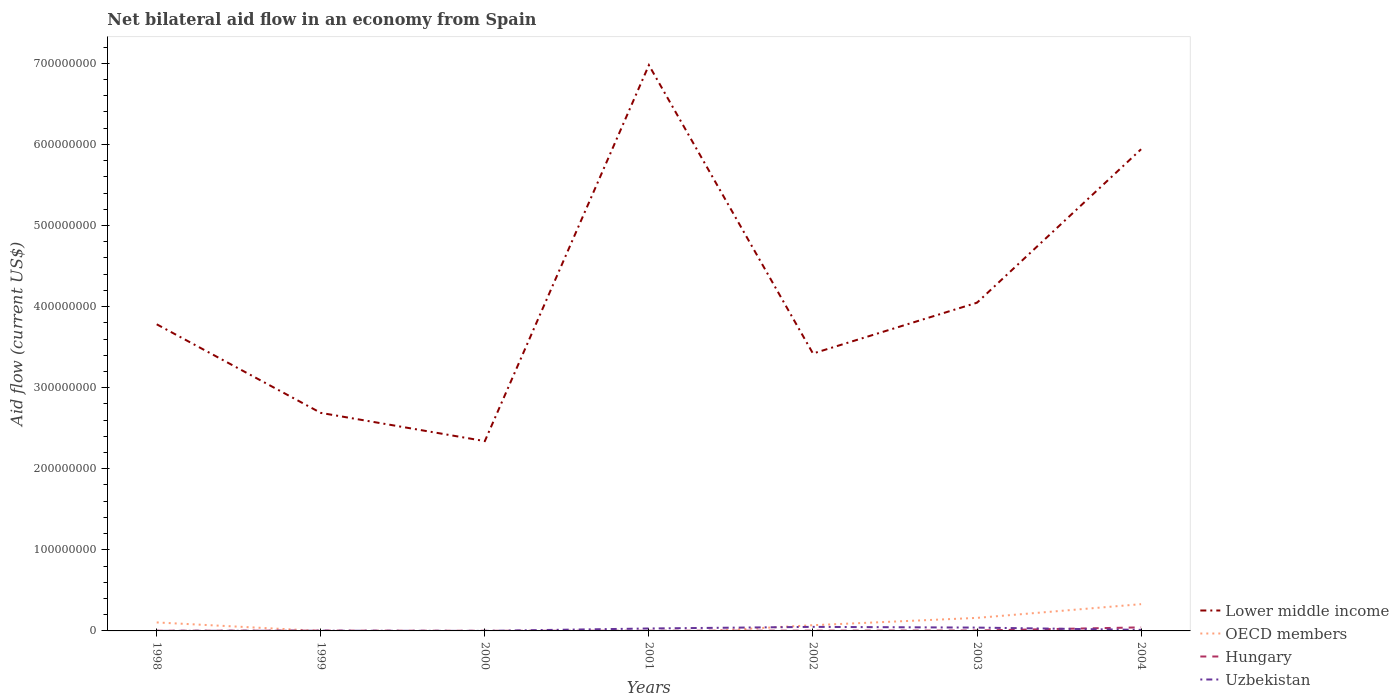Across all years, what is the maximum net bilateral aid flow in Uzbekistan?
Your answer should be very brief. 3.00e+04. What is the total net bilateral aid flow in Uzbekistan in the graph?
Your response must be concise. -4.92e+06. What is the difference between the highest and the second highest net bilateral aid flow in Lower middle income?
Keep it short and to the point. 4.64e+08. What is the difference between the highest and the lowest net bilateral aid flow in Hungary?
Your answer should be compact. 1. How many lines are there?
Provide a short and direct response. 4. How many years are there in the graph?
Your answer should be very brief. 7. Does the graph contain any zero values?
Ensure brevity in your answer.  Yes. Where does the legend appear in the graph?
Offer a very short reply. Bottom right. What is the title of the graph?
Provide a succinct answer. Net bilateral aid flow in an economy from Spain. What is the label or title of the X-axis?
Your answer should be compact. Years. What is the Aid flow (current US$) in Lower middle income in 1998?
Keep it short and to the point. 3.78e+08. What is the Aid flow (current US$) of OECD members in 1998?
Keep it short and to the point. 1.05e+07. What is the Aid flow (current US$) in Uzbekistan in 1998?
Offer a terse response. 7.00e+04. What is the Aid flow (current US$) in Lower middle income in 1999?
Your answer should be very brief. 2.69e+08. What is the Aid flow (current US$) of OECD members in 1999?
Your response must be concise. 0. What is the Aid flow (current US$) in Uzbekistan in 1999?
Offer a very short reply. 2.40e+05. What is the Aid flow (current US$) of Lower middle income in 2000?
Provide a short and direct response. 2.34e+08. What is the Aid flow (current US$) of Hungary in 2000?
Provide a short and direct response. 1.70e+05. What is the Aid flow (current US$) in Uzbekistan in 2000?
Offer a terse response. 3.00e+04. What is the Aid flow (current US$) in Lower middle income in 2001?
Offer a terse response. 6.98e+08. What is the Aid flow (current US$) of OECD members in 2001?
Your answer should be very brief. 0. What is the Aid flow (current US$) in Uzbekistan in 2001?
Give a very brief answer. 3.01e+06. What is the Aid flow (current US$) in Lower middle income in 2002?
Give a very brief answer. 3.42e+08. What is the Aid flow (current US$) of OECD members in 2002?
Give a very brief answer. 7.06e+06. What is the Aid flow (current US$) in Hungary in 2002?
Keep it short and to the point. 3.60e+05. What is the Aid flow (current US$) of Uzbekistan in 2002?
Your response must be concise. 4.99e+06. What is the Aid flow (current US$) of Lower middle income in 2003?
Ensure brevity in your answer.  4.05e+08. What is the Aid flow (current US$) of OECD members in 2003?
Your answer should be very brief. 1.61e+07. What is the Aid flow (current US$) of Hungary in 2003?
Provide a succinct answer. 5.20e+05. What is the Aid flow (current US$) of Uzbekistan in 2003?
Ensure brevity in your answer.  4.11e+06. What is the Aid flow (current US$) of Lower middle income in 2004?
Provide a short and direct response. 5.94e+08. What is the Aid flow (current US$) of OECD members in 2004?
Make the answer very short. 3.30e+07. What is the Aid flow (current US$) in Hungary in 2004?
Keep it short and to the point. 4.39e+06. What is the Aid flow (current US$) in Uzbekistan in 2004?
Offer a terse response. 1.28e+06. Across all years, what is the maximum Aid flow (current US$) of Lower middle income?
Give a very brief answer. 6.98e+08. Across all years, what is the maximum Aid flow (current US$) in OECD members?
Provide a succinct answer. 3.30e+07. Across all years, what is the maximum Aid flow (current US$) in Hungary?
Your response must be concise. 4.39e+06. Across all years, what is the maximum Aid flow (current US$) in Uzbekistan?
Make the answer very short. 4.99e+06. Across all years, what is the minimum Aid flow (current US$) in Lower middle income?
Offer a terse response. 2.34e+08. What is the total Aid flow (current US$) of Lower middle income in the graph?
Provide a short and direct response. 2.92e+09. What is the total Aid flow (current US$) of OECD members in the graph?
Make the answer very short. 6.66e+07. What is the total Aid flow (current US$) of Hungary in the graph?
Offer a terse response. 6.27e+06. What is the total Aid flow (current US$) of Uzbekistan in the graph?
Offer a very short reply. 1.37e+07. What is the difference between the Aid flow (current US$) of Lower middle income in 1998 and that in 1999?
Offer a very short reply. 1.09e+08. What is the difference between the Aid flow (current US$) of Hungary in 1998 and that in 1999?
Your answer should be very brief. -1.50e+05. What is the difference between the Aid flow (current US$) of Uzbekistan in 1998 and that in 1999?
Your answer should be very brief. -1.70e+05. What is the difference between the Aid flow (current US$) of Lower middle income in 1998 and that in 2000?
Offer a terse response. 1.44e+08. What is the difference between the Aid flow (current US$) in Hungary in 1998 and that in 2000?
Make the answer very short. 6.00e+04. What is the difference between the Aid flow (current US$) in Uzbekistan in 1998 and that in 2000?
Offer a very short reply. 4.00e+04. What is the difference between the Aid flow (current US$) in Lower middle income in 1998 and that in 2001?
Your response must be concise. -3.20e+08. What is the difference between the Aid flow (current US$) in Hungary in 1998 and that in 2001?
Give a very brief answer. 10000. What is the difference between the Aid flow (current US$) of Uzbekistan in 1998 and that in 2001?
Your answer should be very brief. -2.94e+06. What is the difference between the Aid flow (current US$) of Lower middle income in 1998 and that in 2002?
Ensure brevity in your answer.  3.60e+07. What is the difference between the Aid flow (current US$) in OECD members in 1998 and that in 2002?
Offer a terse response. 3.41e+06. What is the difference between the Aid flow (current US$) of Hungary in 1998 and that in 2002?
Your answer should be compact. -1.30e+05. What is the difference between the Aid flow (current US$) of Uzbekistan in 1998 and that in 2002?
Provide a short and direct response. -4.92e+06. What is the difference between the Aid flow (current US$) in Lower middle income in 1998 and that in 2003?
Your response must be concise. -2.66e+07. What is the difference between the Aid flow (current US$) in OECD members in 1998 and that in 2003?
Provide a succinct answer. -5.61e+06. What is the difference between the Aid flow (current US$) of Uzbekistan in 1998 and that in 2003?
Provide a succinct answer. -4.04e+06. What is the difference between the Aid flow (current US$) of Lower middle income in 1998 and that in 2004?
Provide a succinct answer. -2.16e+08. What is the difference between the Aid flow (current US$) in OECD members in 1998 and that in 2004?
Offer a terse response. -2.25e+07. What is the difference between the Aid flow (current US$) in Hungary in 1998 and that in 2004?
Your response must be concise. -4.16e+06. What is the difference between the Aid flow (current US$) in Uzbekistan in 1998 and that in 2004?
Your answer should be compact. -1.21e+06. What is the difference between the Aid flow (current US$) of Lower middle income in 1999 and that in 2000?
Your answer should be compact. 3.48e+07. What is the difference between the Aid flow (current US$) in Uzbekistan in 1999 and that in 2000?
Provide a short and direct response. 2.10e+05. What is the difference between the Aid flow (current US$) of Lower middle income in 1999 and that in 2001?
Offer a very short reply. -4.29e+08. What is the difference between the Aid flow (current US$) in Hungary in 1999 and that in 2001?
Provide a short and direct response. 1.60e+05. What is the difference between the Aid flow (current US$) of Uzbekistan in 1999 and that in 2001?
Your answer should be compact. -2.77e+06. What is the difference between the Aid flow (current US$) in Lower middle income in 1999 and that in 2002?
Make the answer very short. -7.32e+07. What is the difference between the Aid flow (current US$) in Uzbekistan in 1999 and that in 2002?
Ensure brevity in your answer.  -4.75e+06. What is the difference between the Aid flow (current US$) in Lower middle income in 1999 and that in 2003?
Your answer should be very brief. -1.36e+08. What is the difference between the Aid flow (current US$) in Hungary in 1999 and that in 2003?
Provide a short and direct response. -1.40e+05. What is the difference between the Aid flow (current US$) of Uzbekistan in 1999 and that in 2003?
Your response must be concise. -3.87e+06. What is the difference between the Aid flow (current US$) of Lower middle income in 1999 and that in 2004?
Make the answer very short. -3.25e+08. What is the difference between the Aid flow (current US$) in Hungary in 1999 and that in 2004?
Give a very brief answer. -4.01e+06. What is the difference between the Aid flow (current US$) of Uzbekistan in 1999 and that in 2004?
Provide a succinct answer. -1.04e+06. What is the difference between the Aid flow (current US$) of Lower middle income in 2000 and that in 2001?
Offer a very short reply. -4.64e+08. What is the difference between the Aid flow (current US$) of Hungary in 2000 and that in 2001?
Offer a very short reply. -5.00e+04. What is the difference between the Aid flow (current US$) in Uzbekistan in 2000 and that in 2001?
Offer a terse response. -2.98e+06. What is the difference between the Aid flow (current US$) in Lower middle income in 2000 and that in 2002?
Keep it short and to the point. -1.08e+08. What is the difference between the Aid flow (current US$) in Uzbekistan in 2000 and that in 2002?
Make the answer very short. -4.96e+06. What is the difference between the Aid flow (current US$) in Lower middle income in 2000 and that in 2003?
Keep it short and to the point. -1.71e+08. What is the difference between the Aid flow (current US$) in Hungary in 2000 and that in 2003?
Your response must be concise. -3.50e+05. What is the difference between the Aid flow (current US$) of Uzbekistan in 2000 and that in 2003?
Ensure brevity in your answer.  -4.08e+06. What is the difference between the Aid flow (current US$) of Lower middle income in 2000 and that in 2004?
Ensure brevity in your answer.  -3.60e+08. What is the difference between the Aid flow (current US$) of Hungary in 2000 and that in 2004?
Offer a terse response. -4.22e+06. What is the difference between the Aid flow (current US$) of Uzbekistan in 2000 and that in 2004?
Keep it short and to the point. -1.25e+06. What is the difference between the Aid flow (current US$) of Lower middle income in 2001 and that in 2002?
Ensure brevity in your answer.  3.56e+08. What is the difference between the Aid flow (current US$) in Hungary in 2001 and that in 2002?
Offer a very short reply. -1.40e+05. What is the difference between the Aid flow (current US$) of Uzbekistan in 2001 and that in 2002?
Keep it short and to the point. -1.98e+06. What is the difference between the Aid flow (current US$) of Lower middle income in 2001 and that in 2003?
Offer a very short reply. 2.93e+08. What is the difference between the Aid flow (current US$) of Hungary in 2001 and that in 2003?
Make the answer very short. -3.00e+05. What is the difference between the Aid flow (current US$) of Uzbekistan in 2001 and that in 2003?
Offer a very short reply. -1.10e+06. What is the difference between the Aid flow (current US$) in Lower middle income in 2001 and that in 2004?
Your response must be concise. 1.04e+08. What is the difference between the Aid flow (current US$) of Hungary in 2001 and that in 2004?
Ensure brevity in your answer.  -4.17e+06. What is the difference between the Aid flow (current US$) of Uzbekistan in 2001 and that in 2004?
Your answer should be very brief. 1.73e+06. What is the difference between the Aid flow (current US$) of Lower middle income in 2002 and that in 2003?
Offer a very short reply. -6.27e+07. What is the difference between the Aid flow (current US$) in OECD members in 2002 and that in 2003?
Make the answer very short. -9.02e+06. What is the difference between the Aid flow (current US$) in Hungary in 2002 and that in 2003?
Your response must be concise. -1.60e+05. What is the difference between the Aid flow (current US$) of Uzbekistan in 2002 and that in 2003?
Give a very brief answer. 8.80e+05. What is the difference between the Aid flow (current US$) in Lower middle income in 2002 and that in 2004?
Ensure brevity in your answer.  -2.52e+08. What is the difference between the Aid flow (current US$) of OECD members in 2002 and that in 2004?
Your answer should be compact. -2.59e+07. What is the difference between the Aid flow (current US$) in Hungary in 2002 and that in 2004?
Your answer should be very brief. -4.03e+06. What is the difference between the Aid flow (current US$) in Uzbekistan in 2002 and that in 2004?
Provide a short and direct response. 3.71e+06. What is the difference between the Aid flow (current US$) of Lower middle income in 2003 and that in 2004?
Your response must be concise. -1.89e+08. What is the difference between the Aid flow (current US$) in OECD members in 2003 and that in 2004?
Offer a very short reply. -1.69e+07. What is the difference between the Aid flow (current US$) of Hungary in 2003 and that in 2004?
Make the answer very short. -3.87e+06. What is the difference between the Aid flow (current US$) in Uzbekistan in 2003 and that in 2004?
Keep it short and to the point. 2.83e+06. What is the difference between the Aid flow (current US$) in Lower middle income in 1998 and the Aid flow (current US$) in Hungary in 1999?
Give a very brief answer. 3.78e+08. What is the difference between the Aid flow (current US$) in Lower middle income in 1998 and the Aid flow (current US$) in Uzbekistan in 1999?
Provide a short and direct response. 3.78e+08. What is the difference between the Aid flow (current US$) in OECD members in 1998 and the Aid flow (current US$) in Hungary in 1999?
Ensure brevity in your answer.  1.01e+07. What is the difference between the Aid flow (current US$) of OECD members in 1998 and the Aid flow (current US$) of Uzbekistan in 1999?
Ensure brevity in your answer.  1.02e+07. What is the difference between the Aid flow (current US$) in Hungary in 1998 and the Aid flow (current US$) in Uzbekistan in 1999?
Ensure brevity in your answer.  -10000. What is the difference between the Aid flow (current US$) of Lower middle income in 1998 and the Aid flow (current US$) of Hungary in 2000?
Ensure brevity in your answer.  3.78e+08. What is the difference between the Aid flow (current US$) of Lower middle income in 1998 and the Aid flow (current US$) of Uzbekistan in 2000?
Offer a very short reply. 3.78e+08. What is the difference between the Aid flow (current US$) in OECD members in 1998 and the Aid flow (current US$) in Hungary in 2000?
Provide a succinct answer. 1.03e+07. What is the difference between the Aid flow (current US$) of OECD members in 1998 and the Aid flow (current US$) of Uzbekistan in 2000?
Offer a very short reply. 1.04e+07. What is the difference between the Aid flow (current US$) of Hungary in 1998 and the Aid flow (current US$) of Uzbekistan in 2000?
Your answer should be very brief. 2.00e+05. What is the difference between the Aid flow (current US$) of Lower middle income in 1998 and the Aid flow (current US$) of Hungary in 2001?
Give a very brief answer. 3.78e+08. What is the difference between the Aid flow (current US$) of Lower middle income in 1998 and the Aid flow (current US$) of Uzbekistan in 2001?
Your answer should be compact. 3.75e+08. What is the difference between the Aid flow (current US$) of OECD members in 1998 and the Aid flow (current US$) of Hungary in 2001?
Your answer should be compact. 1.02e+07. What is the difference between the Aid flow (current US$) in OECD members in 1998 and the Aid flow (current US$) in Uzbekistan in 2001?
Give a very brief answer. 7.46e+06. What is the difference between the Aid flow (current US$) in Hungary in 1998 and the Aid flow (current US$) in Uzbekistan in 2001?
Make the answer very short. -2.78e+06. What is the difference between the Aid flow (current US$) of Lower middle income in 1998 and the Aid flow (current US$) of OECD members in 2002?
Your answer should be compact. 3.71e+08. What is the difference between the Aid flow (current US$) in Lower middle income in 1998 and the Aid flow (current US$) in Hungary in 2002?
Your answer should be very brief. 3.78e+08. What is the difference between the Aid flow (current US$) in Lower middle income in 1998 and the Aid flow (current US$) in Uzbekistan in 2002?
Make the answer very short. 3.73e+08. What is the difference between the Aid flow (current US$) of OECD members in 1998 and the Aid flow (current US$) of Hungary in 2002?
Ensure brevity in your answer.  1.01e+07. What is the difference between the Aid flow (current US$) in OECD members in 1998 and the Aid flow (current US$) in Uzbekistan in 2002?
Ensure brevity in your answer.  5.48e+06. What is the difference between the Aid flow (current US$) in Hungary in 1998 and the Aid flow (current US$) in Uzbekistan in 2002?
Offer a very short reply. -4.76e+06. What is the difference between the Aid flow (current US$) in Lower middle income in 1998 and the Aid flow (current US$) in OECD members in 2003?
Give a very brief answer. 3.62e+08. What is the difference between the Aid flow (current US$) of Lower middle income in 1998 and the Aid flow (current US$) of Hungary in 2003?
Offer a terse response. 3.78e+08. What is the difference between the Aid flow (current US$) of Lower middle income in 1998 and the Aid flow (current US$) of Uzbekistan in 2003?
Provide a succinct answer. 3.74e+08. What is the difference between the Aid flow (current US$) of OECD members in 1998 and the Aid flow (current US$) of Hungary in 2003?
Your answer should be compact. 9.95e+06. What is the difference between the Aid flow (current US$) of OECD members in 1998 and the Aid flow (current US$) of Uzbekistan in 2003?
Provide a succinct answer. 6.36e+06. What is the difference between the Aid flow (current US$) in Hungary in 1998 and the Aid flow (current US$) in Uzbekistan in 2003?
Provide a short and direct response. -3.88e+06. What is the difference between the Aid flow (current US$) of Lower middle income in 1998 and the Aid flow (current US$) of OECD members in 2004?
Ensure brevity in your answer.  3.45e+08. What is the difference between the Aid flow (current US$) in Lower middle income in 1998 and the Aid flow (current US$) in Hungary in 2004?
Provide a succinct answer. 3.74e+08. What is the difference between the Aid flow (current US$) of Lower middle income in 1998 and the Aid flow (current US$) of Uzbekistan in 2004?
Make the answer very short. 3.77e+08. What is the difference between the Aid flow (current US$) of OECD members in 1998 and the Aid flow (current US$) of Hungary in 2004?
Offer a very short reply. 6.08e+06. What is the difference between the Aid flow (current US$) of OECD members in 1998 and the Aid flow (current US$) of Uzbekistan in 2004?
Offer a terse response. 9.19e+06. What is the difference between the Aid flow (current US$) of Hungary in 1998 and the Aid flow (current US$) of Uzbekistan in 2004?
Keep it short and to the point. -1.05e+06. What is the difference between the Aid flow (current US$) of Lower middle income in 1999 and the Aid flow (current US$) of Hungary in 2000?
Provide a short and direct response. 2.69e+08. What is the difference between the Aid flow (current US$) of Lower middle income in 1999 and the Aid flow (current US$) of Uzbekistan in 2000?
Provide a short and direct response. 2.69e+08. What is the difference between the Aid flow (current US$) in Lower middle income in 1999 and the Aid flow (current US$) in Hungary in 2001?
Provide a short and direct response. 2.69e+08. What is the difference between the Aid flow (current US$) of Lower middle income in 1999 and the Aid flow (current US$) of Uzbekistan in 2001?
Offer a very short reply. 2.66e+08. What is the difference between the Aid flow (current US$) in Hungary in 1999 and the Aid flow (current US$) in Uzbekistan in 2001?
Offer a very short reply. -2.63e+06. What is the difference between the Aid flow (current US$) in Lower middle income in 1999 and the Aid flow (current US$) in OECD members in 2002?
Your response must be concise. 2.62e+08. What is the difference between the Aid flow (current US$) in Lower middle income in 1999 and the Aid flow (current US$) in Hungary in 2002?
Your response must be concise. 2.69e+08. What is the difference between the Aid flow (current US$) in Lower middle income in 1999 and the Aid flow (current US$) in Uzbekistan in 2002?
Your answer should be very brief. 2.64e+08. What is the difference between the Aid flow (current US$) of Hungary in 1999 and the Aid flow (current US$) of Uzbekistan in 2002?
Your answer should be compact. -4.61e+06. What is the difference between the Aid flow (current US$) in Lower middle income in 1999 and the Aid flow (current US$) in OECD members in 2003?
Your answer should be very brief. 2.53e+08. What is the difference between the Aid flow (current US$) in Lower middle income in 1999 and the Aid flow (current US$) in Hungary in 2003?
Ensure brevity in your answer.  2.68e+08. What is the difference between the Aid flow (current US$) of Lower middle income in 1999 and the Aid flow (current US$) of Uzbekistan in 2003?
Offer a terse response. 2.65e+08. What is the difference between the Aid flow (current US$) of Hungary in 1999 and the Aid flow (current US$) of Uzbekistan in 2003?
Offer a terse response. -3.73e+06. What is the difference between the Aid flow (current US$) in Lower middle income in 1999 and the Aid flow (current US$) in OECD members in 2004?
Give a very brief answer. 2.36e+08. What is the difference between the Aid flow (current US$) of Lower middle income in 1999 and the Aid flow (current US$) of Hungary in 2004?
Your answer should be very brief. 2.64e+08. What is the difference between the Aid flow (current US$) in Lower middle income in 1999 and the Aid flow (current US$) in Uzbekistan in 2004?
Offer a terse response. 2.68e+08. What is the difference between the Aid flow (current US$) in Hungary in 1999 and the Aid flow (current US$) in Uzbekistan in 2004?
Give a very brief answer. -9.00e+05. What is the difference between the Aid flow (current US$) in Lower middle income in 2000 and the Aid flow (current US$) in Hungary in 2001?
Make the answer very short. 2.34e+08. What is the difference between the Aid flow (current US$) in Lower middle income in 2000 and the Aid flow (current US$) in Uzbekistan in 2001?
Offer a terse response. 2.31e+08. What is the difference between the Aid flow (current US$) of Hungary in 2000 and the Aid flow (current US$) of Uzbekistan in 2001?
Offer a terse response. -2.84e+06. What is the difference between the Aid flow (current US$) of Lower middle income in 2000 and the Aid flow (current US$) of OECD members in 2002?
Offer a terse response. 2.27e+08. What is the difference between the Aid flow (current US$) in Lower middle income in 2000 and the Aid flow (current US$) in Hungary in 2002?
Make the answer very short. 2.34e+08. What is the difference between the Aid flow (current US$) in Lower middle income in 2000 and the Aid flow (current US$) in Uzbekistan in 2002?
Offer a terse response. 2.29e+08. What is the difference between the Aid flow (current US$) in Hungary in 2000 and the Aid flow (current US$) in Uzbekistan in 2002?
Keep it short and to the point. -4.82e+06. What is the difference between the Aid flow (current US$) of Lower middle income in 2000 and the Aid flow (current US$) of OECD members in 2003?
Ensure brevity in your answer.  2.18e+08. What is the difference between the Aid flow (current US$) in Lower middle income in 2000 and the Aid flow (current US$) in Hungary in 2003?
Your response must be concise. 2.34e+08. What is the difference between the Aid flow (current US$) of Lower middle income in 2000 and the Aid flow (current US$) of Uzbekistan in 2003?
Give a very brief answer. 2.30e+08. What is the difference between the Aid flow (current US$) of Hungary in 2000 and the Aid flow (current US$) of Uzbekistan in 2003?
Your response must be concise. -3.94e+06. What is the difference between the Aid flow (current US$) in Lower middle income in 2000 and the Aid flow (current US$) in OECD members in 2004?
Keep it short and to the point. 2.01e+08. What is the difference between the Aid flow (current US$) in Lower middle income in 2000 and the Aid flow (current US$) in Hungary in 2004?
Give a very brief answer. 2.30e+08. What is the difference between the Aid flow (current US$) in Lower middle income in 2000 and the Aid flow (current US$) in Uzbekistan in 2004?
Your answer should be compact. 2.33e+08. What is the difference between the Aid flow (current US$) in Hungary in 2000 and the Aid flow (current US$) in Uzbekistan in 2004?
Offer a very short reply. -1.11e+06. What is the difference between the Aid flow (current US$) of Lower middle income in 2001 and the Aid flow (current US$) of OECD members in 2002?
Provide a short and direct response. 6.91e+08. What is the difference between the Aid flow (current US$) of Lower middle income in 2001 and the Aid flow (current US$) of Hungary in 2002?
Offer a terse response. 6.97e+08. What is the difference between the Aid flow (current US$) in Lower middle income in 2001 and the Aid flow (current US$) in Uzbekistan in 2002?
Offer a terse response. 6.93e+08. What is the difference between the Aid flow (current US$) of Hungary in 2001 and the Aid flow (current US$) of Uzbekistan in 2002?
Your answer should be very brief. -4.77e+06. What is the difference between the Aid flow (current US$) in Lower middle income in 2001 and the Aid flow (current US$) in OECD members in 2003?
Your answer should be very brief. 6.82e+08. What is the difference between the Aid flow (current US$) of Lower middle income in 2001 and the Aid flow (current US$) of Hungary in 2003?
Your answer should be very brief. 6.97e+08. What is the difference between the Aid flow (current US$) of Lower middle income in 2001 and the Aid flow (current US$) of Uzbekistan in 2003?
Provide a short and direct response. 6.94e+08. What is the difference between the Aid flow (current US$) of Hungary in 2001 and the Aid flow (current US$) of Uzbekistan in 2003?
Give a very brief answer. -3.89e+06. What is the difference between the Aid flow (current US$) of Lower middle income in 2001 and the Aid flow (current US$) of OECD members in 2004?
Ensure brevity in your answer.  6.65e+08. What is the difference between the Aid flow (current US$) of Lower middle income in 2001 and the Aid flow (current US$) of Hungary in 2004?
Offer a very short reply. 6.93e+08. What is the difference between the Aid flow (current US$) in Lower middle income in 2001 and the Aid flow (current US$) in Uzbekistan in 2004?
Your answer should be very brief. 6.96e+08. What is the difference between the Aid flow (current US$) in Hungary in 2001 and the Aid flow (current US$) in Uzbekistan in 2004?
Your answer should be very brief. -1.06e+06. What is the difference between the Aid flow (current US$) in Lower middle income in 2002 and the Aid flow (current US$) in OECD members in 2003?
Make the answer very short. 3.26e+08. What is the difference between the Aid flow (current US$) of Lower middle income in 2002 and the Aid flow (current US$) of Hungary in 2003?
Your response must be concise. 3.42e+08. What is the difference between the Aid flow (current US$) of Lower middle income in 2002 and the Aid flow (current US$) of Uzbekistan in 2003?
Provide a short and direct response. 3.38e+08. What is the difference between the Aid flow (current US$) in OECD members in 2002 and the Aid flow (current US$) in Hungary in 2003?
Provide a short and direct response. 6.54e+06. What is the difference between the Aid flow (current US$) of OECD members in 2002 and the Aid flow (current US$) of Uzbekistan in 2003?
Offer a very short reply. 2.95e+06. What is the difference between the Aid flow (current US$) of Hungary in 2002 and the Aid flow (current US$) of Uzbekistan in 2003?
Provide a succinct answer. -3.75e+06. What is the difference between the Aid flow (current US$) in Lower middle income in 2002 and the Aid flow (current US$) in OECD members in 2004?
Offer a very short reply. 3.09e+08. What is the difference between the Aid flow (current US$) of Lower middle income in 2002 and the Aid flow (current US$) of Hungary in 2004?
Offer a very short reply. 3.38e+08. What is the difference between the Aid flow (current US$) in Lower middle income in 2002 and the Aid flow (current US$) in Uzbekistan in 2004?
Provide a succinct answer. 3.41e+08. What is the difference between the Aid flow (current US$) of OECD members in 2002 and the Aid flow (current US$) of Hungary in 2004?
Your response must be concise. 2.67e+06. What is the difference between the Aid flow (current US$) of OECD members in 2002 and the Aid flow (current US$) of Uzbekistan in 2004?
Give a very brief answer. 5.78e+06. What is the difference between the Aid flow (current US$) in Hungary in 2002 and the Aid flow (current US$) in Uzbekistan in 2004?
Provide a succinct answer. -9.20e+05. What is the difference between the Aid flow (current US$) of Lower middle income in 2003 and the Aid flow (current US$) of OECD members in 2004?
Provide a succinct answer. 3.72e+08. What is the difference between the Aid flow (current US$) in Lower middle income in 2003 and the Aid flow (current US$) in Hungary in 2004?
Your answer should be very brief. 4.00e+08. What is the difference between the Aid flow (current US$) in Lower middle income in 2003 and the Aid flow (current US$) in Uzbekistan in 2004?
Make the answer very short. 4.04e+08. What is the difference between the Aid flow (current US$) in OECD members in 2003 and the Aid flow (current US$) in Hungary in 2004?
Your response must be concise. 1.17e+07. What is the difference between the Aid flow (current US$) in OECD members in 2003 and the Aid flow (current US$) in Uzbekistan in 2004?
Provide a short and direct response. 1.48e+07. What is the difference between the Aid flow (current US$) of Hungary in 2003 and the Aid flow (current US$) of Uzbekistan in 2004?
Make the answer very short. -7.60e+05. What is the average Aid flow (current US$) of Lower middle income per year?
Your response must be concise. 4.17e+08. What is the average Aid flow (current US$) in OECD members per year?
Make the answer very short. 9.52e+06. What is the average Aid flow (current US$) of Hungary per year?
Offer a very short reply. 8.96e+05. What is the average Aid flow (current US$) in Uzbekistan per year?
Provide a succinct answer. 1.96e+06. In the year 1998, what is the difference between the Aid flow (current US$) of Lower middle income and Aid flow (current US$) of OECD members?
Ensure brevity in your answer.  3.68e+08. In the year 1998, what is the difference between the Aid flow (current US$) in Lower middle income and Aid flow (current US$) in Hungary?
Your response must be concise. 3.78e+08. In the year 1998, what is the difference between the Aid flow (current US$) of Lower middle income and Aid flow (current US$) of Uzbekistan?
Your response must be concise. 3.78e+08. In the year 1998, what is the difference between the Aid flow (current US$) in OECD members and Aid flow (current US$) in Hungary?
Make the answer very short. 1.02e+07. In the year 1998, what is the difference between the Aid flow (current US$) in OECD members and Aid flow (current US$) in Uzbekistan?
Provide a short and direct response. 1.04e+07. In the year 1999, what is the difference between the Aid flow (current US$) in Lower middle income and Aid flow (current US$) in Hungary?
Provide a succinct answer. 2.69e+08. In the year 1999, what is the difference between the Aid flow (current US$) in Lower middle income and Aid flow (current US$) in Uzbekistan?
Your answer should be compact. 2.69e+08. In the year 1999, what is the difference between the Aid flow (current US$) of Hungary and Aid flow (current US$) of Uzbekistan?
Provide a succinct answer. 1.40e+05. In the year 2000, what is the difference between the Aid flow (current US$) of Lower middle income and Aid flow (current US$) of Hungary?
Your answer should be very brief. 2.34e+08. In the year 2000, what is the difference between the Aid flow (current US$) in Lower middle income and Aid flow (current US$) in Uzbekistan?
Your response must be concise. 2.34e+08. In the year 2001, what is the difference between the Aid flow (current US$) in Lower middle income and Aid flow (current US$) in Hungary?
Provide a short and direct response. 6.98e+08. In the year 2001, what is the difference between the Aid flow (current US$) of Lower middle income and Aid flow (current US$) of Uzbekistan?
Make the answer very short. 6.95e+08. In the year 2001, what is the difference between the Aid flow (current US$) in Hungary and Aid flow (current US$) in Uzbekistan?
Your answer should be very brief. -2.79e+06. In the year 2002, what is the difference between the Aid flow (current US$) of Lower middle income and Aid flow (current US$) of OECD members?
Keep it short and to the point. 3.35e+08. In the year 2002, what is the difference between the Aid flow (current US$) of Lower middle income and Aid flow (current US$) of Hungary?
Provide a succinct answer. 3.42e+08. In the year 2002, what is the difference between the Aid flow (current US$) in Lower middle income and Aid flow (current US$) in Uzbekistan?
Offer a very short reply. 3.37e+08. In the year 2002, what is the difference between the Aid flow (current US$) in OECD members and Aid flow (current US$) in Hungary?
Your response must be concise. 6.70e+06. In the year 2002, what is the difference between the Aid flow (current US$) in OECD members and Aid flow (current US$) in Uzbekistan?
Offer a terse response. 2.07e+06. In the year 2002, what is the difference between the Aid flow (current US$) in Hungary and Aid flow (current US$) in Uzbekistan?
Offer a terse response. -4.63e+06. In the year 2003, what is the difference between the Aid flow (current US$) in Lower middle income and Aid flow (current US$) in OECD members?
Give a very brief answer. 3.89e+08. In the year 2003, what is the difference between the Aid flow (current US$) in Lower middle income and Aid flow (current US$) in Hungary?
Your answer should be very brief. 4.04e+08. In the year 2003, what is the difference between the Aid flow (current US$) in Lower middle income and Aid flow (current US$) in Uzbekistan?
Keep it short and to the point. 4.01e+08. In the year 2003, what is the difference between the Aid flow (current US$) in OECD members and Aid flow (current US$) in Hungary?
Ensure brevity in your answer.  1.56e+07. In the year 2003, what is the difference between the Aid flow (current US$) of OECD members and Aid flow (current US$) of Uzbekistan?
Keep it short and to the point. 1.20e+07. In the year 2003, what is the difference between the Aid flow (current US$) of Hungary and Aid flow (current US$) of Uzbekistan?
Keep it short and to the point. -3.59e+06. In the year 2004, what is the difference between the Aid flow (current US$) of Lower middle income and Aid flow (current US$) of OECD members?
Offer a very short reply. 5.61e+08. In the year 2004, what is the difference between the Aid flow (current US$) of Lower middle income and Aid flow (current US$) of Hungary?
Ensure brevity in your answer.  5.90e+08. In the year 2004, what is the difference between the Aid flow (current US$) of Lower middle income and Aid flow (current US$) of Uzbekistan?
Ensure brevity in your answer.  5.93e+08. In the year 2004, what is the difference between the Aid flow (current US$) in OECD members and Aid flow (current US$) in Hungary?
Your answer should be compact. 2.86e+07. In the year 2004, what is the difference between the Aid flow (current US$) in OECD members and Aid flow (current US$) in Uzbekistan?
Offer a terse response. 3.17e+07. In the year 2004, what is the difference between the Aid flow (current US$) in Hungary and Aid flow (current US$) in Uzbekistan?
Provide a short and direct response. 3.11e+06. What is the ratio of the Aid flow (current US$) in Lower middle income in 1998 to that in 1999?
Ensure brevity in your answer.  1.41. What is the ratio of the Aid flow (current US$) in Hungary in 1998 to that in 1999?
Your answer should be very brief. 0.61. What is the ratio of the Aid flow (current US$) in Uzbekistan in 1998 to that in 1999?
Your response must be concise. 0.29. What is the ratio of the Aid flow (current US$) of Lower middle income in 1998 to that in 2000?
Provide a succinct answer. 1.62. What is the ratio of the Aid flow (current US$) in Hungary in 1998 to that in 2000?
Give a very brief answer. 1.35. What is the ratio of the Aid flow (current US$) in Uzbekistan in 1998 to that in 2000?
Keep it short and to the point. 2.33. What is the ratio of the Aid flow (current US$) in Lower middle income in 1998 to that in 2001?
Your answer should be compact. 0.54. What is the ratio of the Aid flow (current US$) in Hungary in 1998 to that in 2001?
Provide a succinct answer. 1.05. What is the ratio of the Aid flow (current US$) in Uzbekistan in 1998 to that in 2001?
Your response must be concise. 0.02. What is the ratio of the Aid flow (current US$) of Lower middle income in 1998 to that in 2002?
Offer a terse response. 1.11. What is the ratio of the Aid flow (current US$) of OECD members in 1998 to that in 2002?
Offer a very short reply. 1.48. What is the ratio of the Aid flow (current US$) in Hungary in 1998 to that in 2002?
Your answer should be compact. 0.64. What is the ratio of the Aid flow (current US$) in Uzbekistan in 1998 to that in 2002?
Provide a succinct answer. 0.01. What is the ratio of the Aid flow (current US$) in Lower middle income in 1998 to that in 2003?
Your answer should be very brief. 0.93. What is the ratio of the Aid flow (current US$) of OECD members in 1998 to that in 2003?
Keep it short and to the point. 0.65. What is the ratio of the Aid flow (current US$) in Hungary in 1998 to that in 2003?
Offer a terse response. 0.44. What is the ratio of the Aid flow (current US$) of Uzbekistan in 1998 to that in 2003?
Offer a very short reply. 0.02. What is the ratio of the Aid flow (current US$) of Lower middle income in 1998 to that in 2004?
Make the answer very short. 0.64. What is the ratio of the Aid flow (current US$) of OECD members in 1998 to that in 2004?
Provide a succinct answer. 0.32. What is the ratio of the Aid flow (current US$) in Hungary in 1998 to that in 2004?
Provide a short and direct response. 0.05. What is the ratio of the Aid flow (current US$) in Uzbekistan in 1998 to that in 2004?
Ensure brevity in your answer.  0.05. What is the ratio of the Aid flow (current US$) of Lower middle income in 1999 to that in 2000?
Give a very brief answer. 1.15. What is the ratio of the Aid flow (current US$) of Hungary in 1999 to that in 2000?
Give a very brief answer. 2.24. What is the ratio of the Aid flow (current US$) of Uzbekistan in 1999 to that in 2000?
Ensure brevity in your answer.  8. What is the ratio of the Aid flow (current US$) in Lower middle income in 1999 to that in 2001?
Offer a very short reply. 0.39. What is the ratio of the Aid flow (current US$) of Hungary in 1999 to that in 2001?
Keep it short and to the point. 1.73. What is the ratio of the Aid flow (current US$) of Uzbekistan in 1999 to that in 2001?
Your answer should be compact. 0.08. What is the ratio of the Aid flow (current US$) in Lower middle income in 1999 to that in 2002?
Your answer should be compact. 0.79. What is the ratio of the Aid flow (current US$) in Hungary in 1999 to that in 2002?
Offer a very short reply. 1.06. What is the ratio of the Aid flow (current US$) of Uzbekistan in 1999 to that in 2002?
Offer a very short reply. 0.05. What is the ratio of the Aid flow (current US$) of Lower middle income in 1999 to that in 2003?
Ensure brevity in your answer.  0.66. What is the ratio of the Aid flow (current US$) in Hungary in 1999 to that in 2003?
Provide a short and direct response. 0.73. What is the ratio of the Aid flow (current US$) in Uzbekistan in 1999 to that in 2003?
Provide a succinct answer. 0.06. What is the ratio of the Aid flow (current US$) in Lower middle income in 1999 to that in 2004?
Provide a short and direct response. 0.45. What is the ratio of the Aid flow (current US$) in Hungary in 1999 to that in 2004?
Provide a succinct answer. 0.09. What is the ratio of the Aid flow (current US$) of Uzbekistan in 1999 to that in 2004?
Provide a succinct answer. 0.19. What is the ratio of the Aid flow (current US$) of Lower middle income in 2000 to that in 2001?
Give a very brief answer. 0.34. What is the ratio of the Aid flow (current US$) in Hungary in 2000 to that in 2001?
Make the answer very short. 0.77. What is the ratio of the Aid flow (current US$) in Uzbekistan in 2000 to that in 2001?
Offer a very short reply. 0.01. What is the ratio of the Aid flow (current US$) in Lower middle income in 2000 to that in 2002?
Give a very brief answer. 0.68. What is the ratio of the Aid flow (current US$) of Hungary in 2000 to that in 2002?
Your answer should be very brief. 0.47. What is the ratio of the Aid flow (current US$) of Uzbekistan in 2000 to that in 2002?
Provide a succinct answer. 0.01. What is the ratio of the Aid flow (current US$) of Lower middle income in 2000 to that in 2003?
Provide a short and direct response. 0.58. What is the ratio of the Aid flow (current US$) in Hungary in 2000 to that in 2003?
Your answer should be very brief. 0.33. What is the ratio of the Aid flow (current US$) in Uzbekistan in 2000 to that in 2003?
Offer a terse response. 0.01. What is the ratio of the Aid flow (current US$) of Lower middle income in 2000 to that in 2004?
Provide a short and direct response. 0.39. What is the ratio of the Aid flow (current US$) of Hungary in 2000 to that in 2004?
Your answer should be very brief. 0.04. What is the ratio of the Aid flow (current US$) of Uzbekistan in 2000 to that in 2004?
Ensure brevity in your answer.  0.02. What is the ratio of the Aid flow (current US$) of Lower middle income in 2001 to that in 2002?
Make the answer very short. 2.04. What is the ratio of the Aid flow (current US$) in Hungary in 2001 to that in 2002?
Ensure brevity in your answer.  0.61. What is the ratio of the Aid flow (current US$) in Uzbekistan in 2001 to that in 2002?
Offer a terse response. 0.6. What is the ratio of the Aid flow (current US$) in Lower middle income in 2001 to that in 2003?
Keep it short and to the point. 1.72. What is the ratio of the Aid flow (current US$) of Hungary in 2001 to that in 2003?
Ensure brevity in your answer.  0.42. What is the ratio of the Aid flow (current US$) of Uzbekistan in 2001 to that in 2003?
Make the answer very short. 0.73. What is the ratio of the Aid flow (current US$) of Lower middle income in 2001 to that in 2004?
Provide a short and direct response. 1.17. What is the ratio of the Aid flow (current US$) of Hungary in 2001 to that in 2004?
Offer a very short reply. 0.05. What is the ratio of the Aid flow (current US$) in Uzbekistan in 2001 to that in 2004?
Provide a succinct answer. 2.35. What is the ratio of the Aid flow (current US$) of Lower middle income in 2002 to that in 2003?
Provide a succinct answer. 0.85. What is the ratio of the Aid flow (current US$) of OECD members in 2002 to that in 2003?
Give a very brief answer. 0.44. What is the ratio of the Aid flow (current US$) in Hungary in 2002 to that in 2003?
Offer a terse response. 0.69. What is the ratio of the Aid flow (current US$) of Uzbekistan in 2002 to that in 2003?
Offer a very short reply. 1.21. What is the ratio of the Aid flow (current US$) in Lower middle income in 2002 to that in 2004?
Keep it short and to the point. 0.58. What is the ratio of the Aid flow (current US$) in OECD members in 2002 to that in 2004?
Your answer should be compact. 0.21. What is the ratio of the Aid flow (current US$) in Hungary in 2002 to that in 2004?
Offer a terse response. 0.08. What is the ratio of the Aid flow (current US$) of Uzbekistan in 2002 to that in 2004?
Offer a terse response. 3.9. What is the ratio of the Aid flow (current US$) of Lower middle income in 2003 to that in 2004?
Your response must be concise. 0.68. What is the ratio of the Aid flow (current US$) in OECD members in 2003 to that in 2004?
Your answer should be compact. 0.49. What is the ratio of the Aid flow (current US$) of Hungary in 2003 to that in 2004?
Provide a succinct answer. 0.12. What is the ratio of the Aid flow (current US$) of Uzbekistan in 2003 to that in 2004?
Give a very brief answer. 3.21. What is the difference between the highest and the second highest Aid flow (current US$) in Lower middle income?
Provide a succinct answer. 1.04e+08. What is the difference between the highest and the second highest Aid flow (current US$) in OECD members?
Provide a short and direct response. 1.69e+07. What is the difference between the highest and the second highest Aid flow (current US$) of Hungary?
Provide a short and direct response. 3.87e+06. What is the difference between the highest and the second highest Aid flow (current US$) of Uzbekistan?
Provide a short and direct response. 8.80e+05. What is the difference between the highest and the lowest Aid flow (current US$) of Lower middle income?
Offer a terse response. 4.64e+08. What is the difference between the highest and the lowest Aid flow (current US$) in OECD members?
Your response must be concise. 3.30e+07. What is the difference between the highest and the lowest Aid flow (current US$) of Hungary?
Give a very brief answer. 4.22e+06. What is the difference between the highest and the lowest Aid flow (current US$) of Uzbekistan?
Provide a succinct answer. 4.96e+06. 